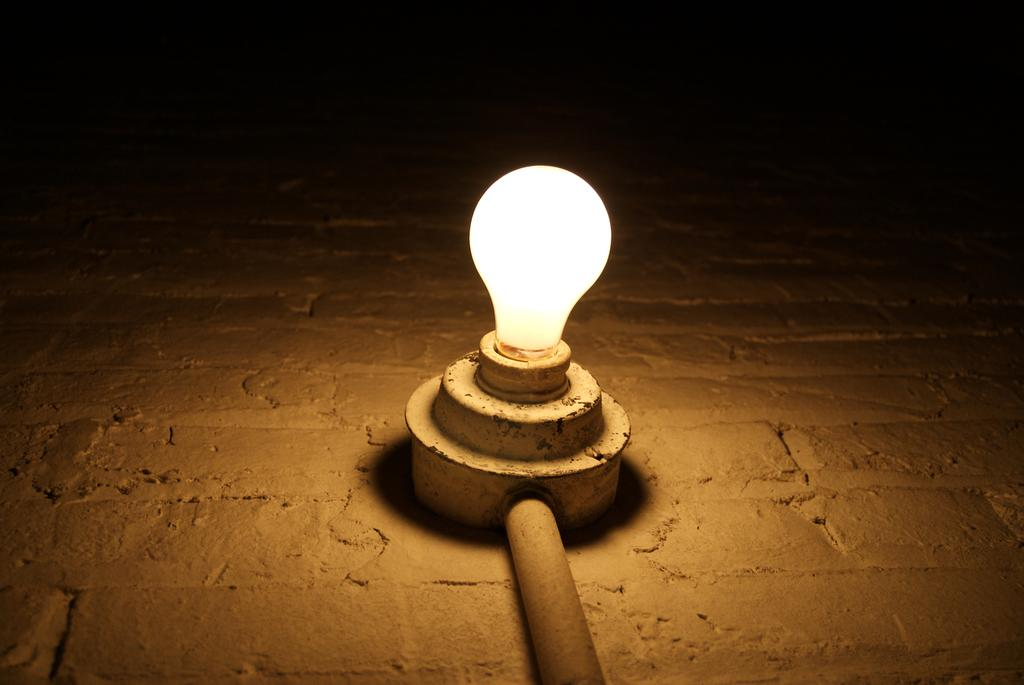What is the main object in the center of the image? There is a light in the center of the image. Can you describe the overall lighting in the image? The image is a little bit dark. What type of steam can be seen coming from the light in the image? There is no steam present in the image; it only features a light. 